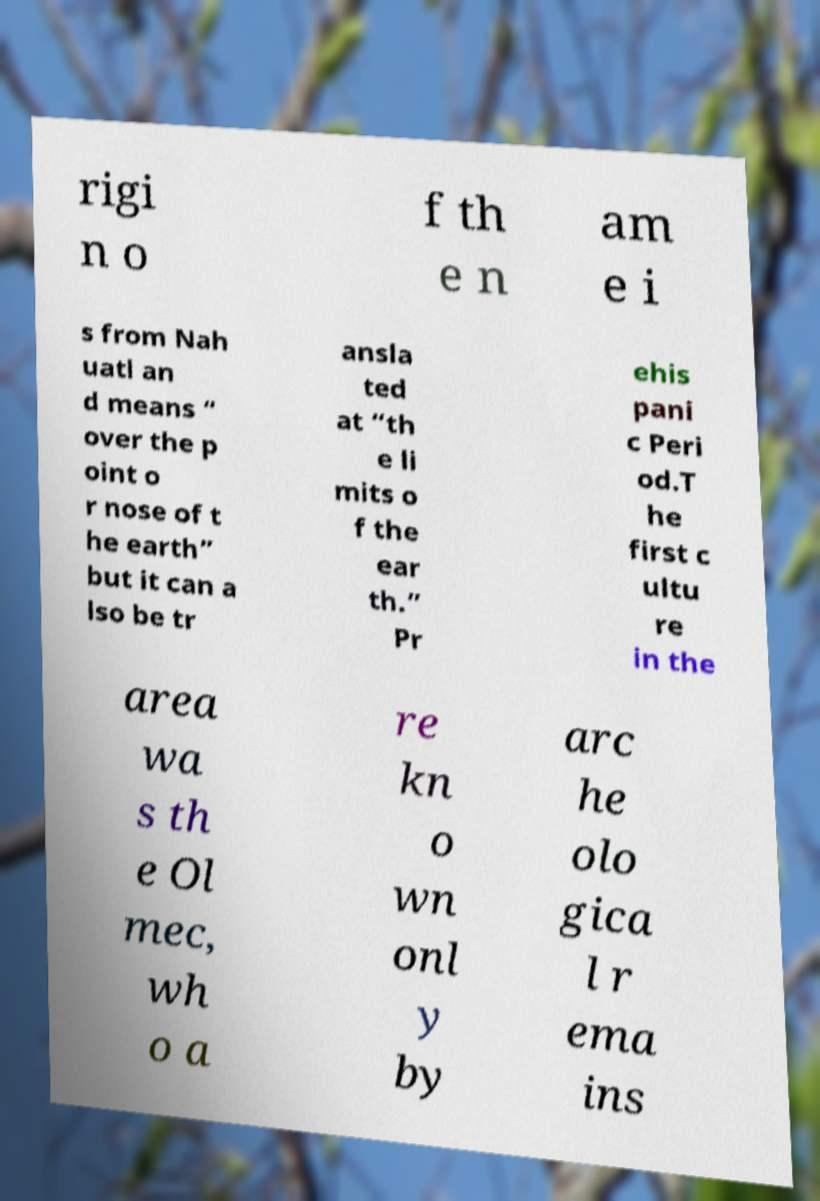Can you read and provide the text displayed in the image?This photo seems to have some interesting text. Can you extract and type it out for me? rigi n o f th e n am e i s from Nah uatl an d means “ over the p oint o r nose of t he earth” but it can a lso be tr ansla ted at “th e li mits o f the ear th.” Pr ehis pani c Peri od.T he first c ultu re in the area wa s th e Ol mec, wh o a re kn o wn onl y by arc he olo gica l r ema ins 